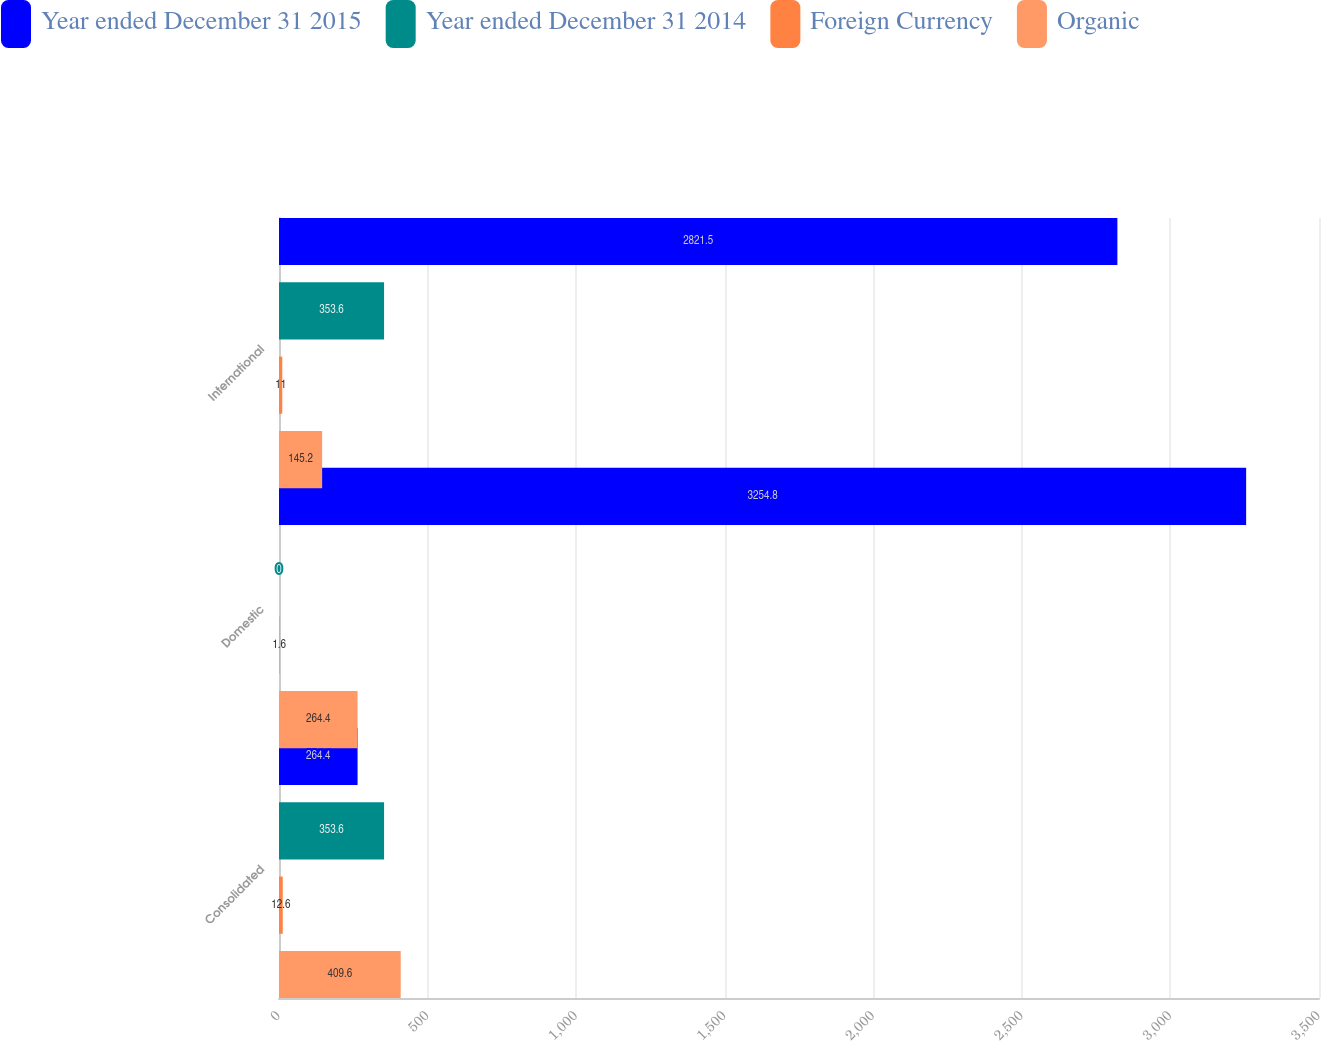Convert chart to OTSL. <chart><loc_0><loc_0><loc_500><loc_500><stacked_bar_chart><ecel><fcel>Consolidated<fcel>Domestic<fcel>International<nl><fcel>Year ended December 31 2015<fcel>264.4<fcel>3254.8<fcel>2821.5<nl><fcel>Year ended December 31 2014<fcel>353.6<fcel>0<fcel>353.6<nl><fcel>Foreign Currency<fcel>12.6<fcel>1.6<fcel>11<nl><fcel>Organic<fcel>409.6<fcel>264.4<fcel>145.2<nl></chart> 